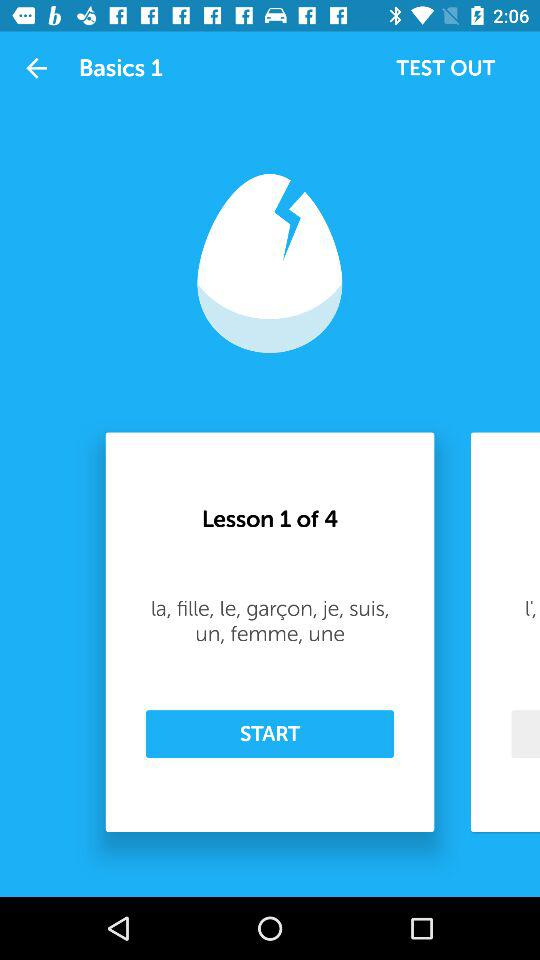Which words are taught in lesson 3?
When the provided information is insufficient, respond with <no answer>. <no answer> 